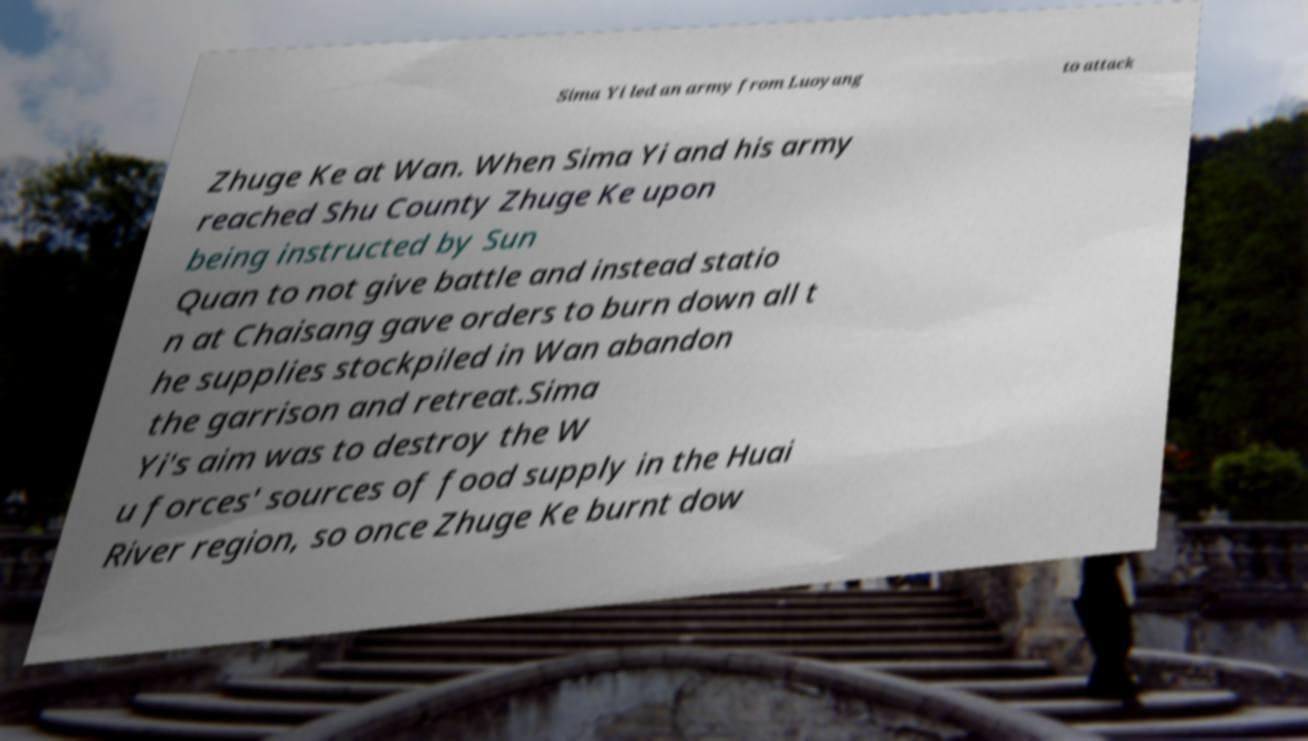For documentation purposes, I need the text within this image transcribed. Could you provide that? Sima Yi led an army from Luoyang to attack Zhuge Ke at Wan. When Sima Yi and his army reached Shu County Zhuge Ke upon being instructed by Sun Quan to not give battle and instead statio n at Chaisang gave orders to burn down all t he supplies stockpiled in Wan abandon the garrison and retreat.Sima Yi's aim was to destroy the W u forces' sources of food supply in the Huai River region, so once Zhuge Ke burnt dow 